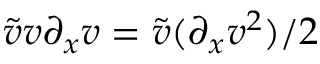<formula> <loc_0><loc_0><loc_500><loc_500>\tilde { v } v \partial _ { x } v = \tilde { v } ( \partial _ { x } v ^ { 2 } ) / 2</formula> 